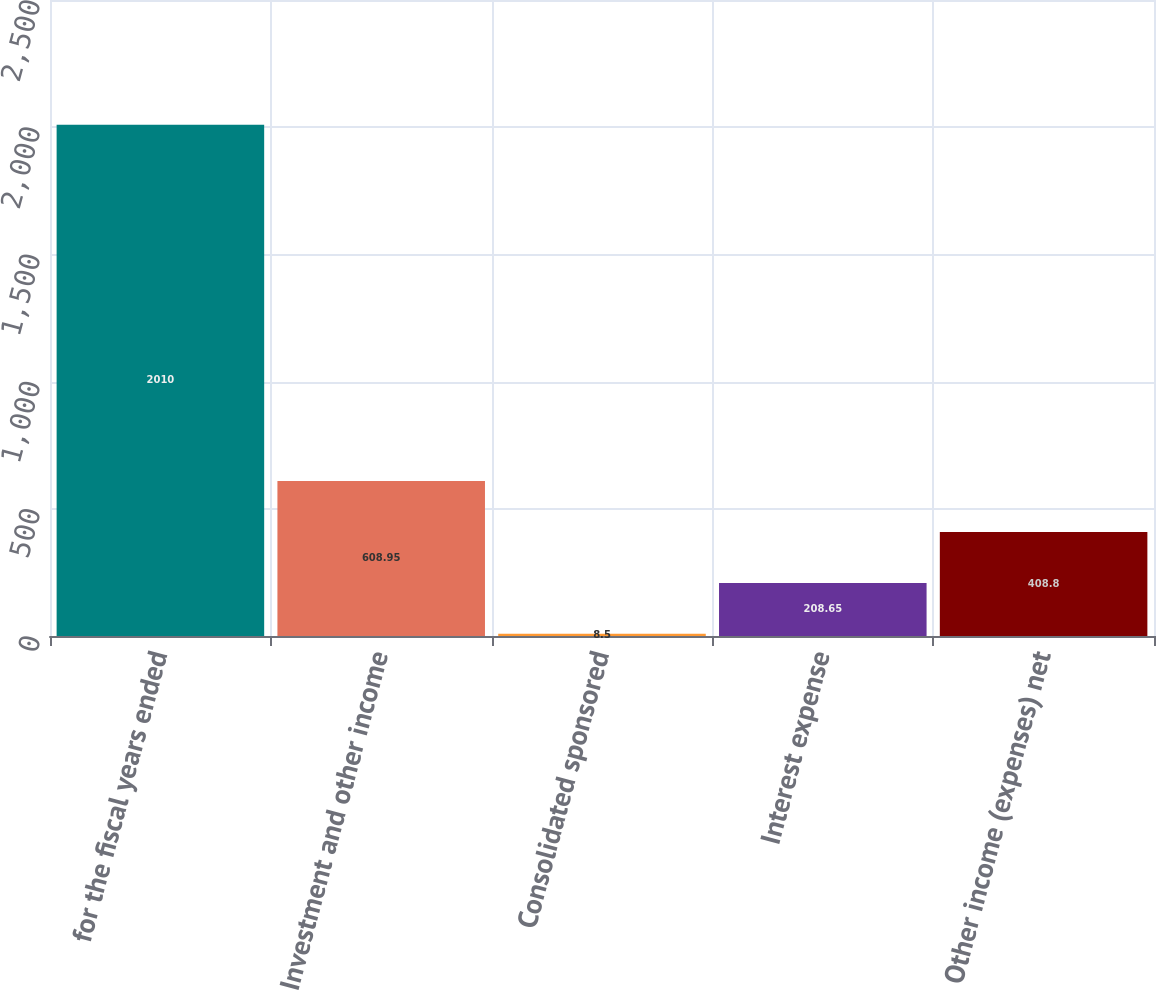Convert chart. <chart><loc_0><loc_0><loc_500><loc_500><bar_chart><fcel>for the fiscal years ended<fcel>Investment and other income<fcel>Consolidated sponsored<fcel>Interest expense<fcel>Other income (expenses) net<nl><fcel>2010<fcel>608.95<fcel>8.5<fcel>208.65<fcel>408.8<nl></chart> 